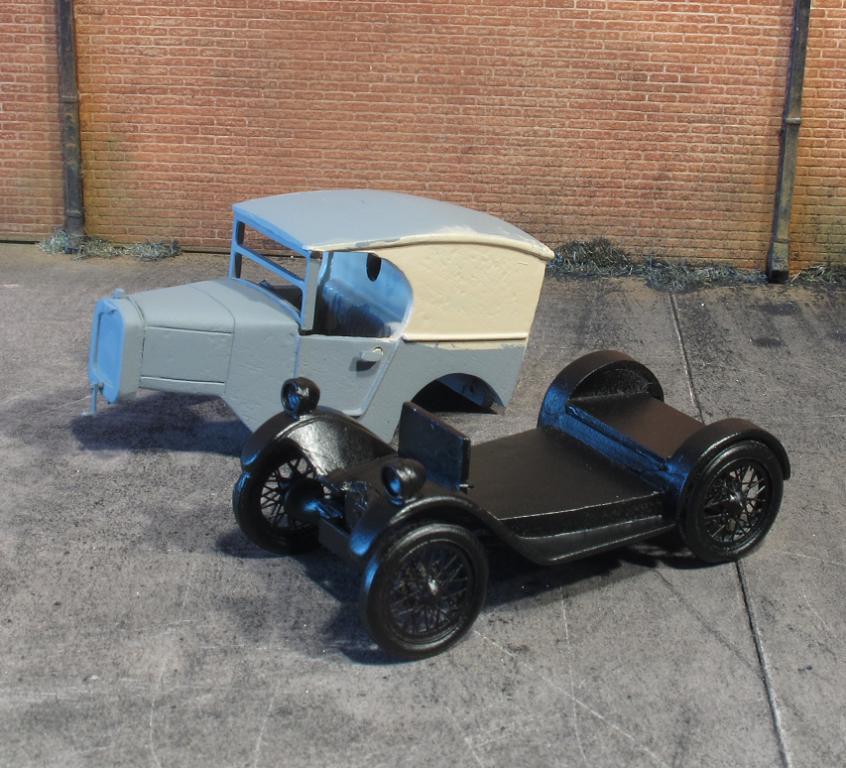Please provide a concise description of this image. In this picture I can see parts of vehicles. In the background I can see a wall of bricks. 